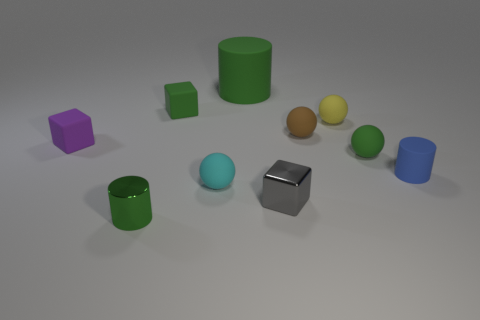Are any small red metal cylinders visible?
Your response must be concise. No. Is the purple thing the same shape as the gray thing?
Offer a terse response. Yes. There is a matte cylinder on the left side of the small ball on the right side of the tiny yellow thing; what number of tiny green matte things are on the right side of it?
Keep it short and to the point. 1. There is a tiny object that is behind the tiny blue cylinder and right of the tiny yellow rubber ball; what is its material?
Provide a succinct answer. Rubber. What color is the matte object that is on the right side of the brown object and in front of the small green rubber sphere?
Your response must be concise. Blue. Are there any other things that have the same color as the small metallic cylinder?
Provide a succinct answer. Yes. What shape is the small green rubber object that is in front of the rubber thing to the left of the matte block that is right of the small shiny cylinder?
Your answer should be compact. Sphere. What color is the other small rubber object that is the same shape as the purple matte object?
Provide a succinct answer. Green. What is the color of the rubber thing behind the tiny green thing that is behind the green matte sphere?
Offer a terse response. Green. What is the size of the other green object that is the same shape as the large green object?
Provide a succinct answer. Small. 